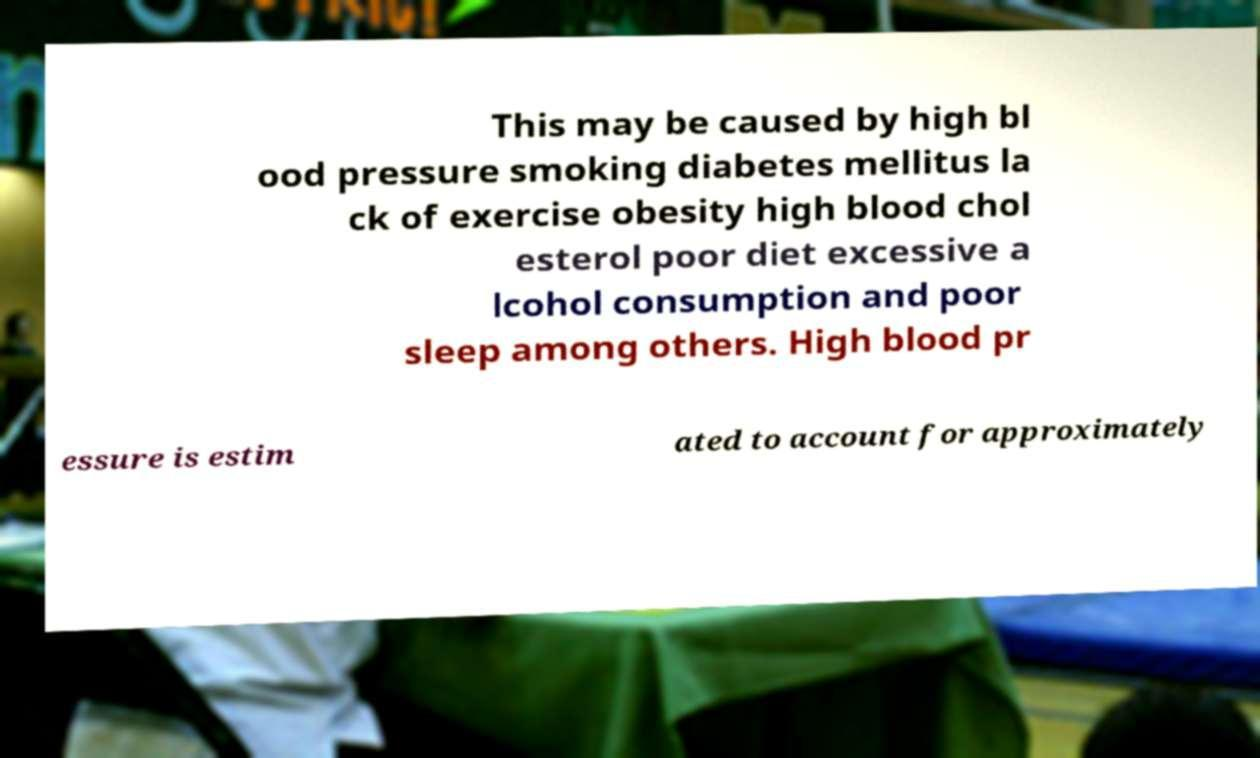What messages or text are displayed in this image? I need them in a readable, typed format. This may be caused by high bl ood pressure smoking diabetes mellitus la ck of exercise obesity high blood chol esterol poor diet excessive a lcohol consumption and poor sleep among others. High blood pr essure is estim ated to account for approximately 